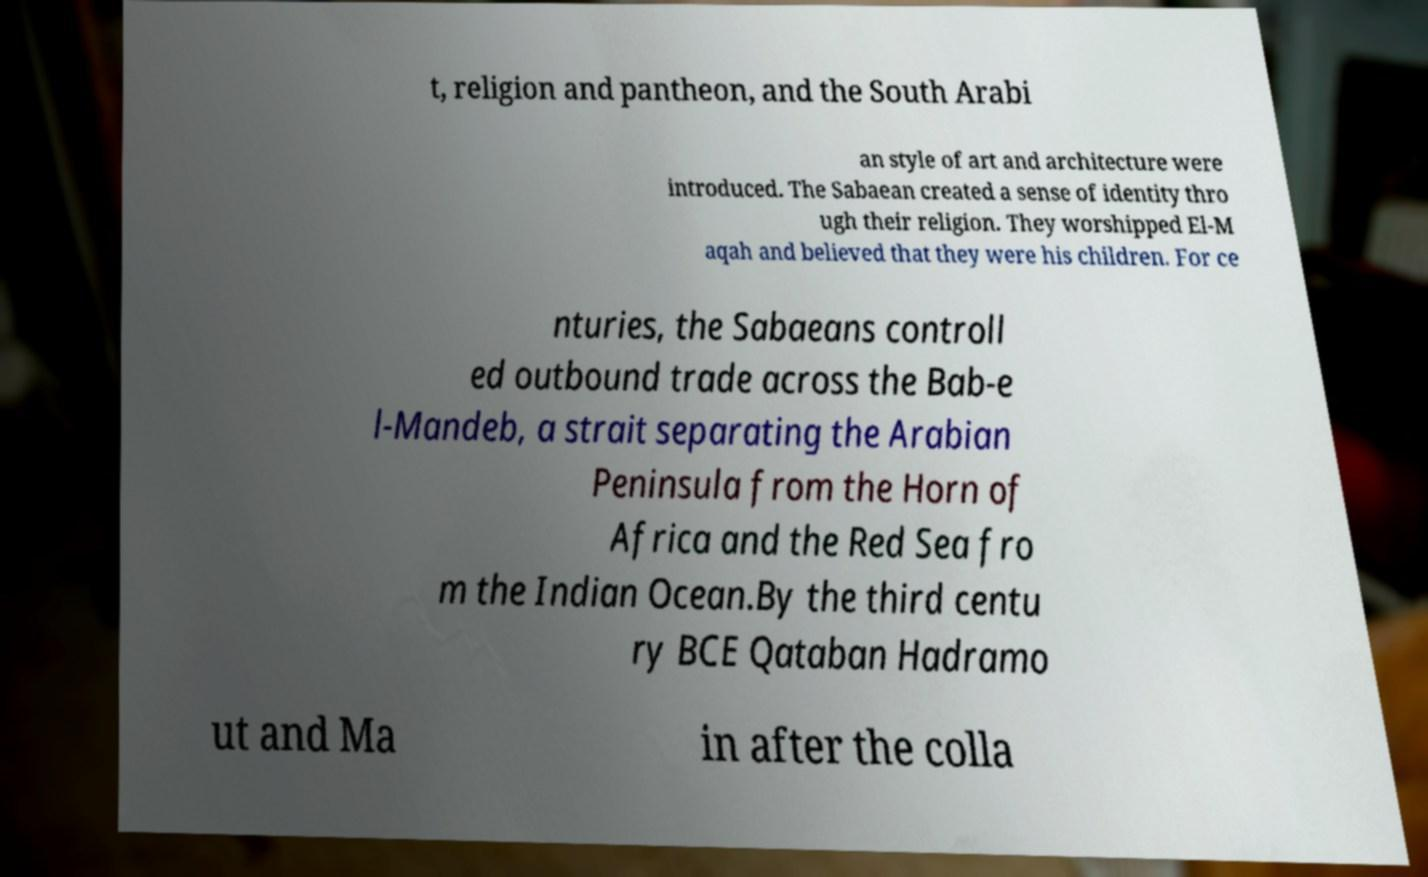What messages or text are displayed in this image? I need them in a readable, typed format. t, religion and pantheon, and the South Arabi an style of art and architecture were introduced. The Sabaean created a sense of identity thro ugh their religion. They worshipped El-M aqah and believed that they were his children. For ce nturies, the Sabaeans controll ed outbound trade across the Bab-e l-Mandeb, a strait separating the Arabian Peninsula from the Horn of Africa and the Red Sea fro m the Indian Ocean.By the third centu ry BCE Qataban Hadramo ut and Ma in after the colla 